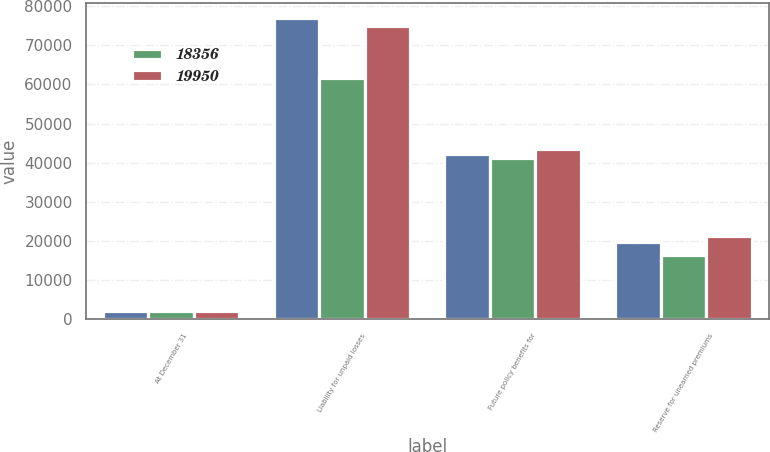Convert chart to OTSL. <chart><loc_0><loc_0><loc_500><loc_500><stacked_bar_chart><ecel><fcel>At December 31<fcel>Liability for unpaid losses<fcel>Future policy benefits for<fcel>Reserve for unearned premiums<nl><fcel>nan<fcel>2016<fcel>77077<fcel>42204<fcel>19634<nl><fcel>18356<fcel>2016<fcel>61545<fcel>41140<fcel>16280<nl><fcel>19950<fcel>2015<fcel>74942<fcel>43585<fcel>21318<nl></chart> 